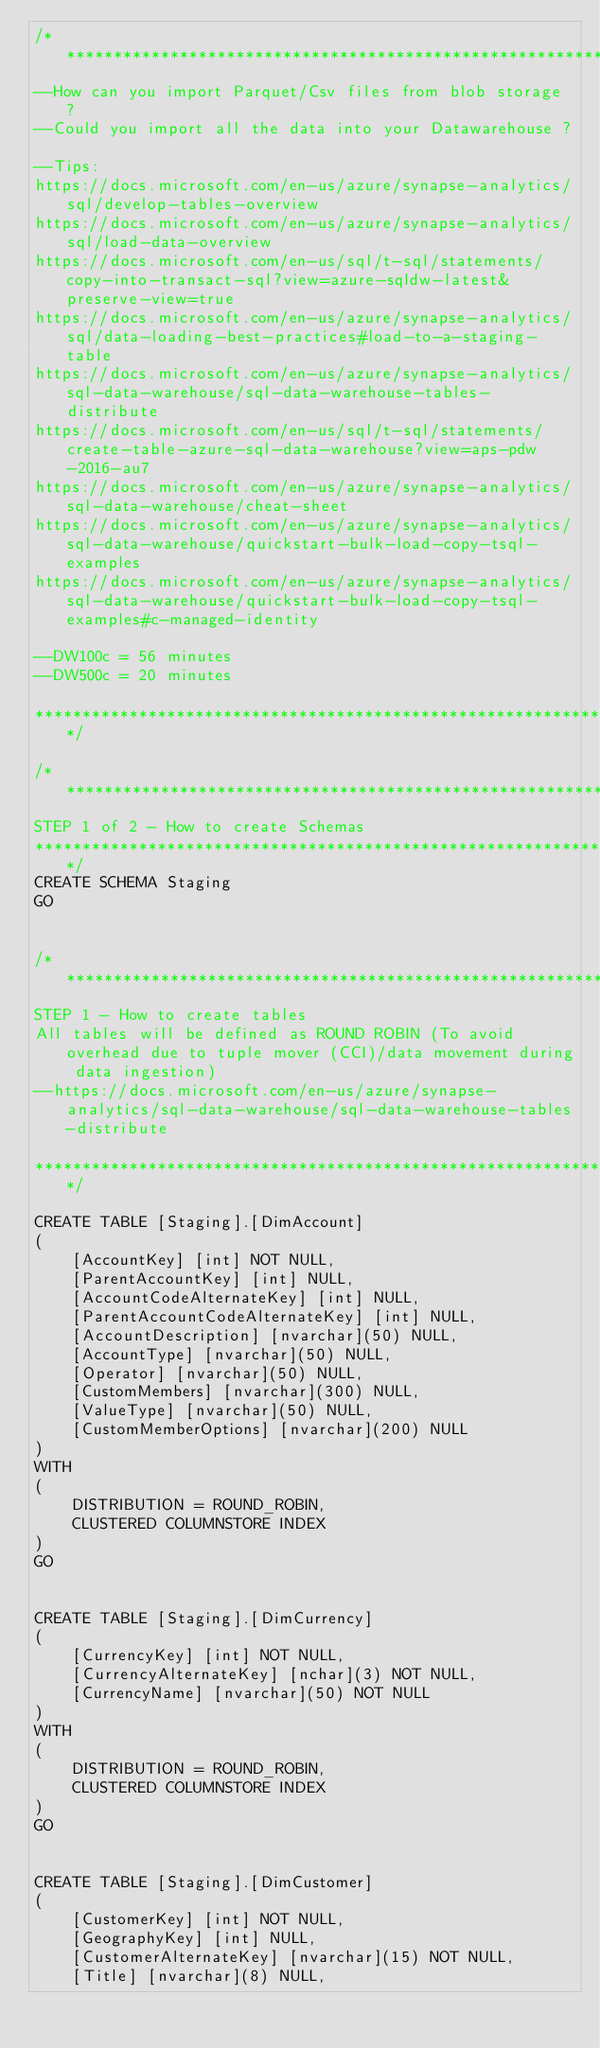<code> <loc_0><loc_0><loc_500><loc_500><_SQL_>/****************************************************************************************
--How can you import Parquet/Csv files from blob storage ?
--Could you import all the data into your Datawarehouse ?

--Tips:
https://docs.microsoft.com/en-us/azure/synapse-analytics/sql/develop-tables-overview
https://docs.microsoft.com/en-us/azure/synapse-analytics/sql/load-data-overview
https://docs.microsoft.com/en-us/sql/t-sql/statements/copy-into-transact-sql?view=azure-sqldw-latest&preserve-view=true
https://docs.microsoft.com/en-us/azure/synapse-analytics/sql/data-loading-best-practices#load-to-a-staging-table
https://docs.microsoft.com/en-us/azure/synapse-analytics/sql-data-warehouse/sql-data-warehouse-tables-distribute
https://docs.microsoft.com/en-us/sql/t-sql/statements/create-table-azure-sql-data-warehouse?view=aps-pdw-2016-au7
https://docs.microsoft.com/en-us/azure/synapse-analytics/sql-data-warehouse/cheat-sheet
https://docs.microsoft.com/en-us/azure/synapse-analytics/sql-data-warehouse/quickstart-bulk-load-copy-tsql-examples
https://docs.microsoft.com/en-us/azure/synapse-analytics/sql-data-warehouse/quickstart-bulk-load-copy-tsql-examples#c-managed-identity

--DW100c = 56 minutes
--DW500c = 20 minutes

****************************************************************************************/

/****************************************************************************************
STEP 1 of 2 - How to create Schemas
****************************************************************************************/
CREATE SCHEMA Staging
GO


/****************************************************************************************
STEP 1 - How to create tables
All tables will be defined as ROUND ROBIN (To avoid overhead due to tuple mover (CCI)/data movement during data ingestion)
--https://docs.microsoft.com/en-us/azure/synapse-analytics/sql-data-warehouse/sql-data-warehouse-tables-distribute

****************************************************************************************/

CREATE TABLE [Staging].[DimAccount]
(	
	[AccountKey] [int] NOT NULL,
	[ParentAccountKey] [int] NULL,
	[AccountCodeAlternateKey] [int] NULL,
	[ParentAccountCodeAlternateKey] [int] NULL,
	[AccountDescription] [nvarchar](50) NULL,
	[AccountType] [nvarchar](50) NULL,
	[Operator] [nvarchar](50) NULL,
	[CustomMembers] [nvarchar](300) NULL,
	[ValueType] [nvarchar](50) NULL,
	[CustomMemberOptions] [nvarchar](200) NULL
)
WITH
(
	DISTRIBUTION = ROUND_ROBIN,
	CLUSTERED COLUMNSTORE INDEX
)
GO


CREATE TABLE [Staging].[DimCurrency]
(
	[CurrencyKey] [int] NOT NULL,
	[CurrencyAlternateKey] [nchar](3) NOT NULL,
	[CurrencyName] [nvarchar](50) NOT NULL
)
WITH
(
	DISTRIBUTION = ROUND_ROBIN,
	CLUSTERED COLUMNSTORE INDEX
)
GO


CREATE TABLE [Staging].[DimCustomer]
(
	[CustomerKey] [int] NOT NULL,
	[GeographyKey] [int] NULL,
	[CustomerAlternateKey] [nvarchar](15) NOT NULL,
	[Title] [nvarchar](8) NULL,</code> 